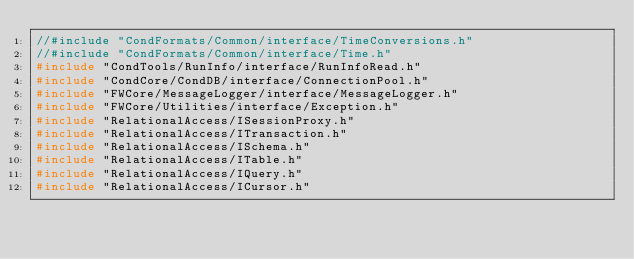<code> <loc_0><loc_0><loc_500><loc_500><_C++_>//#include "CondFormats/Common/interface/TimeConversions.h"
//#include "CondFormats/Common/interface/Time.h"
#include "CondTools/RunInfo/interface/RunInfoRead.h"
#include "CondCore/CondDB/interface/ConnectionPool.h"
#include "FWCore/MessageLogger/interface/MessageLogger.h"
#include "FWCore/Utilities/interface/Exception.h"
#include "RelationalAccess/ISessionProxy.h"
#include "RelationalAccess/ITransaction.h"
#include "RelationalAccess/ISchema.h"
#include "RelationalAccess/ITable.h"
#include "RelationalAccess/IQuery.h"
#include "RelationalAccess/ICursor.h"</code> 